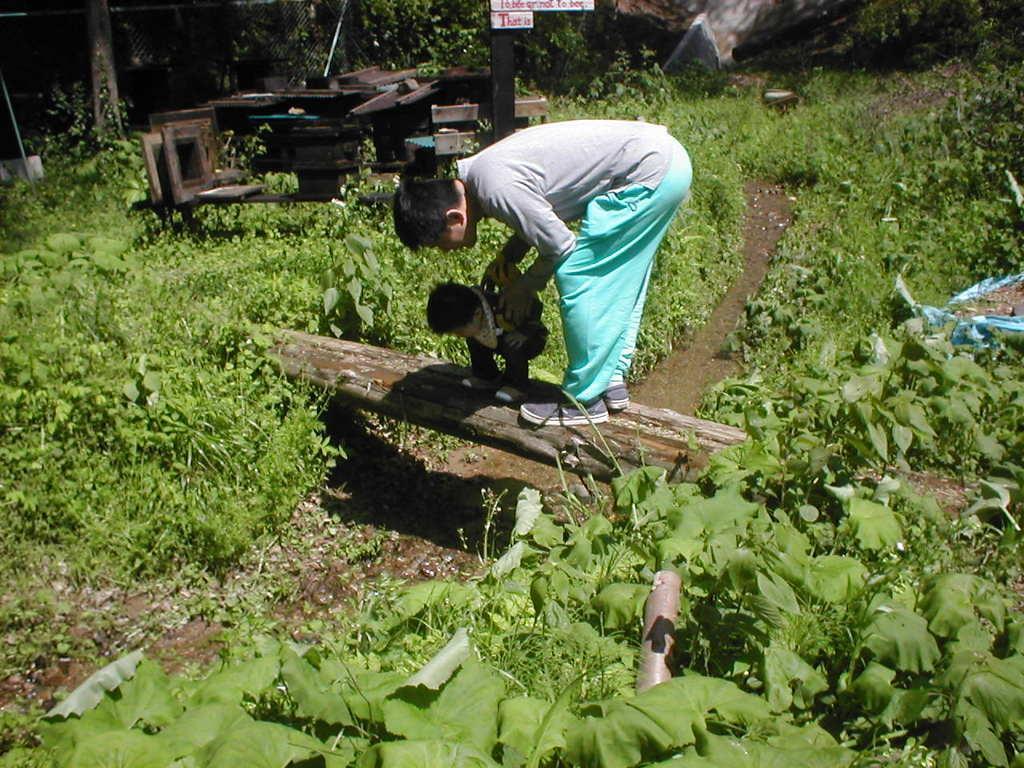In one or two sentences, can you explain what this image depicts? In this image there are two people bending on the wooden pole. Around them there are plants. Behind them there are boards with some text on it and there are some metal objects. On the left side of the image there is a mesh. 